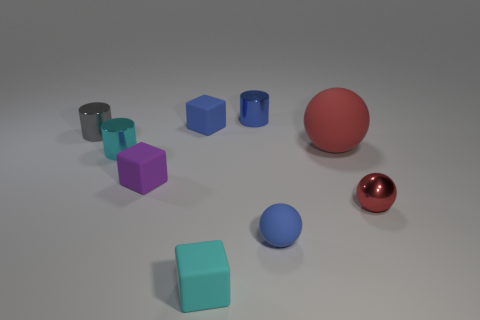Do any of the objects appear to have a reflective surface, and what does that tell us about the material? Yes, the objects with a metallic sheen—specifically the small red sphere and the various cylindrical shapes—have reflective surfaces. These reflections indicate that the materials are likely to be polished metals, as they exhibit sharp, clear reflections of the environment and the other objects in the scene. 